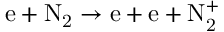Convert formula to latex. <formula><loc_0><loc_0><loc_500><loc_500>e + N _ { 2 } \to e + e + N _ { 2 } ^ { + }</formula> 